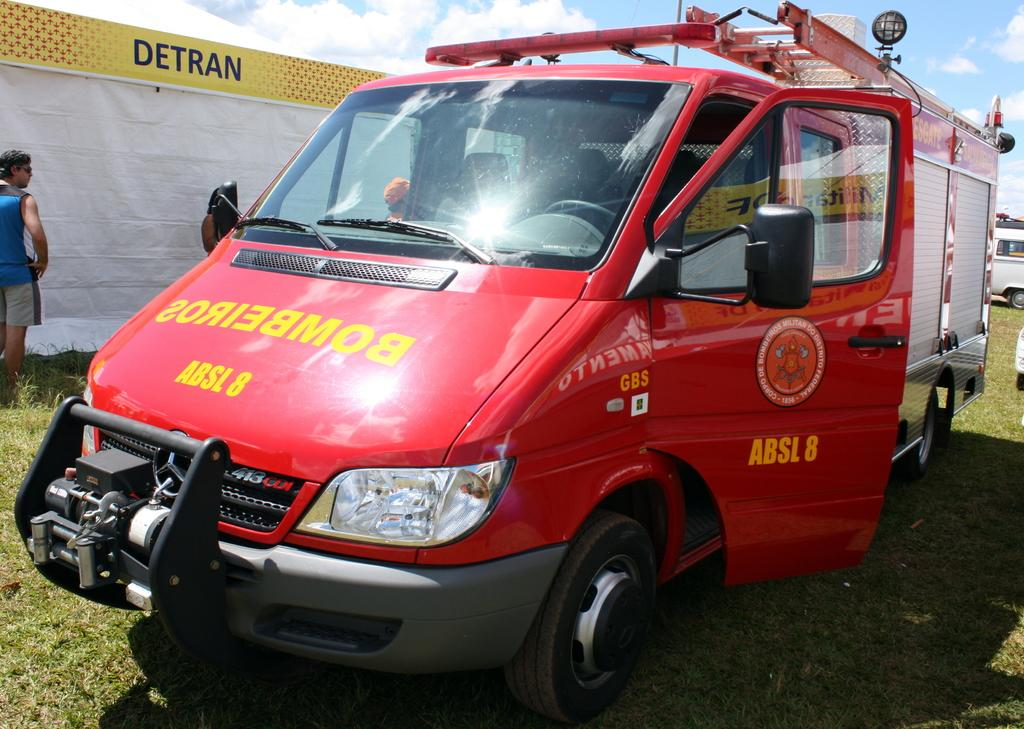<image>
Render a clear and concise summary of the photo. A red Bombeiros truck is parked with the drivers side door open. 